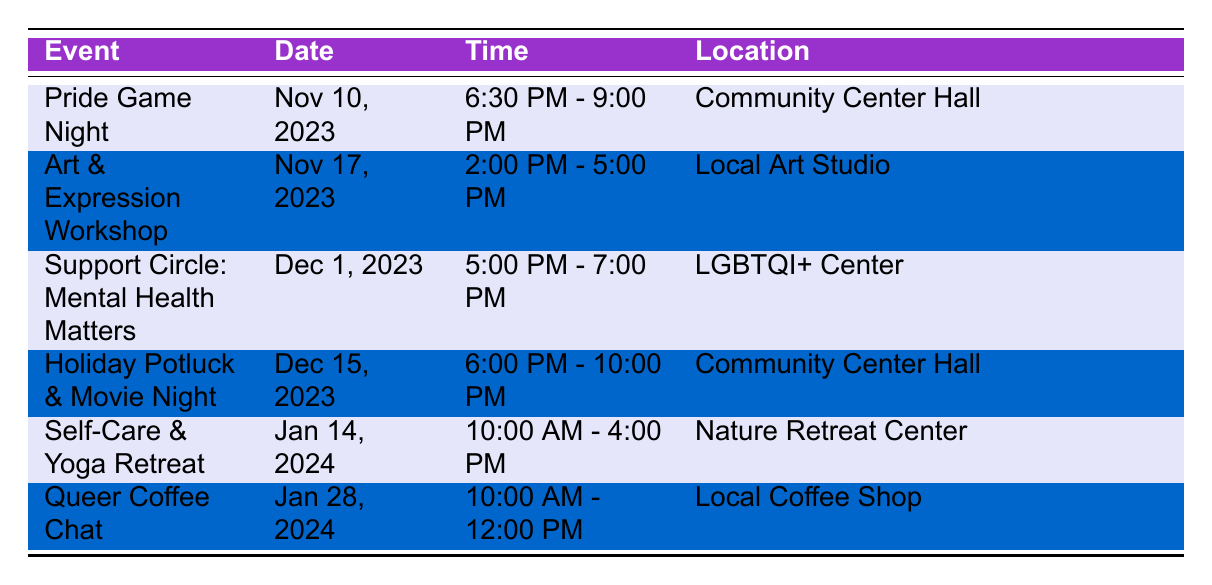What's the date and time for the "Pride Game Night"? The table shows that the "Pride Game Night" is scheduled for November 10, 2023, and the time is from 6:30 PM to 9:00 PM.
Answer: November 10, 2023, 6:30 PM - 9:00 PM Which event takes place at the "LGBTQI+ Center"? The table indicates that the event taking place at the "LGBTQI+ Center" is "Support Circle: Mental Health Matters" on December 1, 2023.
Answer: Support Circle: Mental Health Matters How many total social gatherings are listed in the table? By counting each event listed in the table, there are a total of six social gatherings mentioned.
Answer: 6 What is the duration of the "Self-Care & Yoga Retreat"? The "Self-Care & Yoga Retreat" is on January 14, 2024, from 10:00 AM to 4:00 PM. To find the duration, we calculate: 4 PM - 10 AM = 6 hours.
Answer: 6 hours Is there an event specifically focused on mental health? Yes, the "Support Circle: Mental Health Matters" event is designated specifically for discussing mental health challenges and sharing coping strategies.
Answer: Yes What is the time gap between the "Art & Expression Workshop" and the "Support Circle: Mental Health Matters"? The "Art & Expression Workshop" is on November 17, 2023, from 2:00 PM to 5:00 PM, and the "Support Circle: Mental Health Matters" is on December 1, 2023. There are 14 days between the two dates, making the gap 14 days in total.
Answer: 14 days If you attend both the "Holiday Potluck & Movie Night" and the "Queer Coffee Chat," how many hours will you spend at these events combined? The "Holiday Potluck & Movie Night" is from 6:00 PM to 10:00 PM (4 hours), and the "Queer Coffee Chat" is from 10:00 AM to 12:00 PM (2 hours). Adding these, the total spent is 4 + 2 = 6 hours.
Answer: 6 hours What event is located at the "Local Art Studio"? According to the table, the event at the "Local Art Studio" is the "Art & Expression Workshop" scheduled for November 17, 2023.
Answer: Art & Expression Workshop 